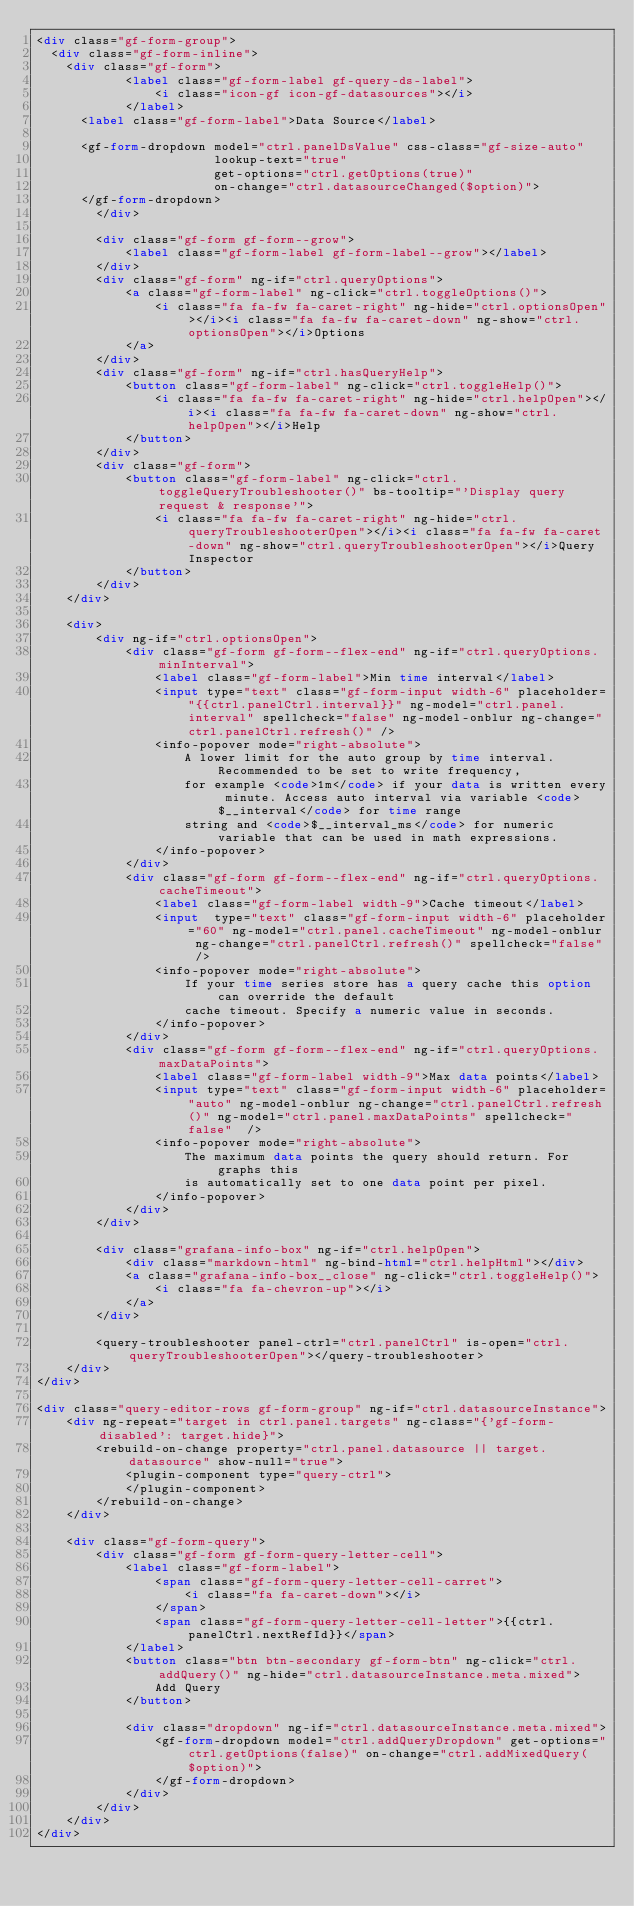Convert code to text. <code><loc_0><loc_0><loc_500><loc_500><_HTML_><div class="gf-form-group">
  <div class="gf-form-inline">
    <div class="gf-form">
			<label class="gf-form-label gf-query-ds-label">
				<i class="icon-gf icon-gf-datasources"></i>
			</label>
      <label class="gf-form-label">Data Source</label>

      <gf-form-dropdown model="ctrl.panelDsValue" css-class="gf-size-auto"
                        lookup-text="true"
                        get-options="ctrl.getOptions(true)"
                        on-change="ctrl.datasourceChanged($option)">
      </gf-form-dropdown>
		</div>

		<div class="gf-form gf-form--grow">
			<label class="gf-form-label gf-form-label--grow"></label>
		</div>
		<div class="gf-form" ng-if="ctrl.queryOptions">
			<a class="gf-form-label" ng-click="ctrl.toggleOptions()">
				<i class="fa fa-fw fa-caret-right" ng-hide="ctrl.optionsOpen"></i><i class="fa fa-fw fa-caret-down" ng-show="ctrl.optionsOpen"></i>Options
			</a>
		</div>
		<div class="gf-form" ng-if="ctrl.hasQueryHelp">
			<button class="gf-form-label" ng-click="ctrl.toggleHelp()">
				<i class="fa fa-fw fa-caret-right" ng-hide="ctrl.helpOpen"></i><i class="fa fa-fw fa-caret-down" ng-show="ctrl.helpOpen"></i>Help
			</button>
		</div>
		<div class="gf-form">
			<button class="gf-form-label" ng-click="ctrl.toggleQueryTroubleshooter()" bs-tooltip="'Display query request & response'">
				<i class="fa fa-fw fa-caret-right" ng-hide="ctrl.queryTroubleshooterOpen"></i><i class="fa fa-fw fa-caret-down" ng-show="ctrl.queryTroubleshooterOpen"></i>Query Inspector
			</button>
		</div>
	</div>

	<div>
		<div ng-if="ctrl.optionsOpen">
			<div class="gf-form gf-form--flex-end" ng-if="ctrl.queryOptions.minInterval">
				<label class="gf-form-label">Min time interval</label>
				<input type="text" class="gf-form-input width-6" placeholder="{{ctrl.panelCtrl.interval}}" ng-model="ctrl.panel.interval" spellcheck="false" ng-model-onblur ng-change="ctrl.panelCtrl.refresh()" />
				<info-popover mode="right-absolute">
					A lower limit for the auto group by time interval. Recommended to be set to write frequency,
					for example <code>1m</code> if your data is written every minute. Access auto interval via variable <code>$__interval</code> for time range
					string and <code>$__interval_ms</code> for numeric variable that can be used in math expressions.
				</info-popover>
			</div>
			<div class="gf-form gf-form--flex-end" ng-if="ctrl.queryOptions.cacheTimeout">
				<label class="gf-form-label width-9">Cache timeout</label>
				<input  type="text" class="gf-form-input width-6" placeholder="60" ng-model="ctrl.panel.cacheTimeout" ng-model-onblur ng-change="ctrl.panelCtrl.refresh()" spellcheck="false" />
				<info-popover mode="right-absolute">
					If your time series store has a query cache this option can override the default
					cache timeout. Specify a numeric value in seconds.
				</info-popover>
			</div>
			<div class="gf-form gf-form--flex-end" ng-if="ctrl.queryOptions.maxDataPoints">
				<label class="gf-form-label width-9">Max data points</label>
				<input type="text" class="gf-form-input width-6" placeholder="auto" ng-model-onblur ng-change="ctrl.panelCtrl.refresh()" ng-model="ctrl.panel.maxDataPoints" spellcheck="false"  />
				<info-popover mode="right-absolute">
					The maximum data points the query should return. For graphs this
					is automatically set to one data point per pixel.
				</info-popover>
			</div>
		</div>

		<div class="grafana-info-box" ng-if="ctrl.helpOpen">
			<div class="markdown-html" ng-bind-html="ctrl.helpHtml"></div>
			<a class="grafana-info-box__close" ng-click="ctrl.toggleHelp()">
				<i class="fa fa-chevron-up"></i>
			</a>
		</div>

		<query-troubleshooter panel-ctrl="ctrl.panelCtrl" is-open="ctrl.queryTroubleshooterOpen"></query-troubleshooter>
	</div>
</div>

<div class="query-editor-rows gf-form-group" ng-if="ctrl.datasourceInstance">
	<div ng-repeat="target in ctrl.panel.targets" ng-class="{'gf-form-disabled': target.hide}">
		<rebuild-on-change property="ctrl.panel.datasource || target.datasource" show-null="true">
			<plugin-component type="query-ctrl">
			</plugin-component>
		</rebuild-on-change>
	</div>

	<div class="gf-form-query">
		<div class="gf-form gf-form-query-letter-cell">
			<label class="gf-form-label">
				<span class="gf-form-query-letter-cell-carret">
					<i class="fa fa-caret-down"></i>
				</span>
				<span class="gf-form-query-letter-cell-letter">{{ctrl.panelCtrl.nextRefId}}</span>
			</label>
			<button class="btn btn-secondary gf-form-btn" ng-click="ctrl.addQuery()" ng-hide="ctrl.datasourceInstance.meta.mixed">
				Add Query
			</button>

			<div class="dropdown" ng-if="ctrl.datasourceInstance.meta.mixed">
				<gf-form-dropdown model="ctrl.addQueryDropdown" get-options="ctrl.getOptions(false)" on-change="ctrl.addMixedQuery($option)">
				</gf-form-dropdown>
			</div>
		</div>
	</div>
</div>
</code> 